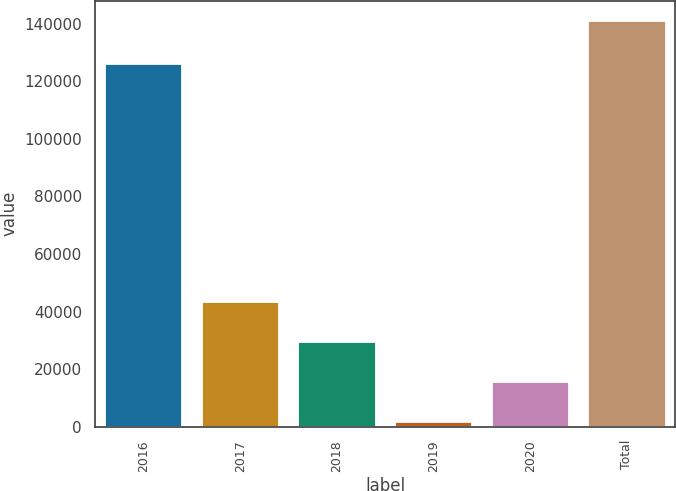Convert chart to OTSL. <chart><loc_0><loc_0><loc_500><loc_500><bar_chart><fcel>2016<fcel>2017<fcel>2018<fcel>2019<fcel>2020<fcel>Total<nl><fcel>126037<fcel>43431.3<fcel>29491.2<fcel>1611<fcel>15551.1<fcel>141012<nl></chart> 